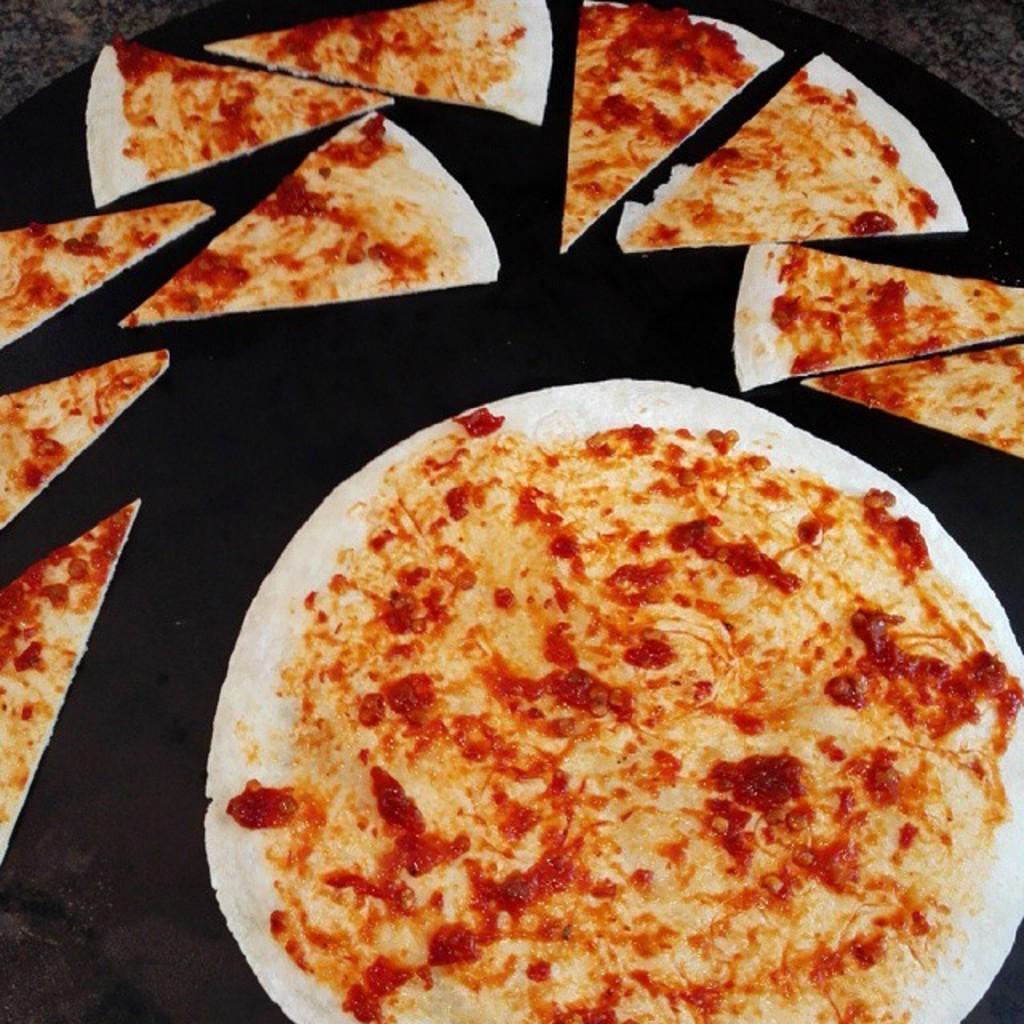How would you summarize this image in a sentence or two? In this image we can see a pizza and some slices of it which are placed on the surface. 